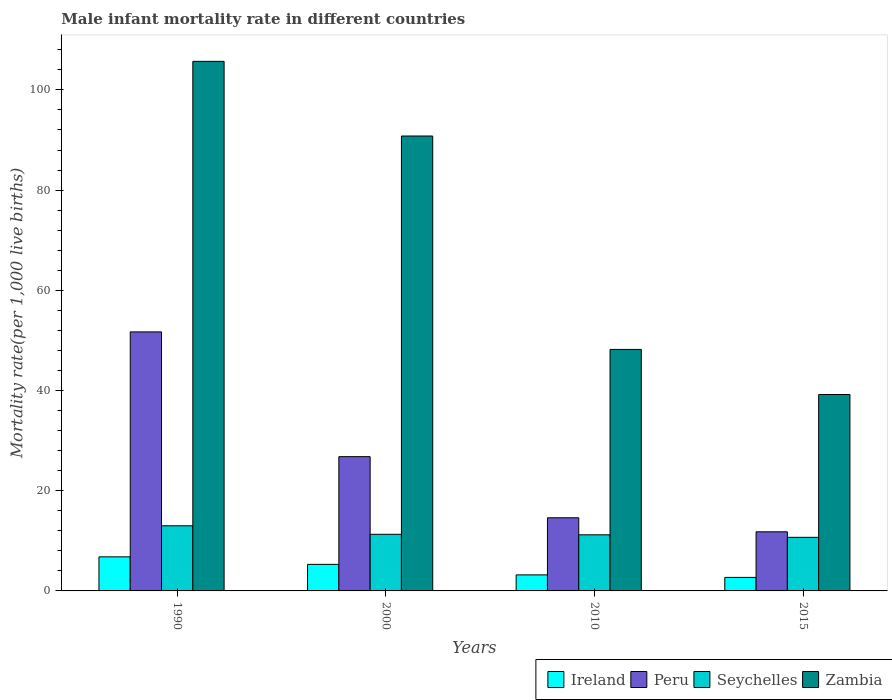How many different coloured bars are there?
Keep it short and to the point. 4. Are the number of bars per tick equal to the number of legend labels?
Your answer should be compact. Yes. How many bars are there on the 1st tick from the right?
Give a very brief answer. 4. What is the label of the 1st group of bars from the left?
Keep it short and to the point. 1990. In how many cases, is the number of bars for a given year not equal to the number of legend labels?
Ensure brevity in your answer.  0. What is the male infant mortality rate in Zambia in 2015?
Ensure brevity in your answer.  39.2. Across all years, what is the maximum male infant mortality rate in Peru?
Ensure brevity in your answer.  51.7. In which year was the male infant mortality rate in Seychelles maximum?
Your answer should be very brief. 1990. In which year was the male infant mortality rate in Seychelles minimum?
Provide a short and direct response. 2015. What is the total male infant mortality rate in Peru in the graph?
Provide a short and direct response. 104.9. What is the difference between the male infant mortality rate in Zambia in 1990 and that in 2010?
Keep it short and to the point. 57.5. What is the average male infant mortality rate in Ireland per year?
Offer a terse response. 4.5. In the year 2010, what is the difference between the male infant mortality rate in Zambia and male infant mortality rate in Seychelles?
Offer a terse response. 37. In how many years, is the male infant mortality rate in Seychelles greater than 16?
Provide a short and direct response. 0. What is the ratio of the male infant mortality rate in Peru in 1990 to that in 2000?
Make the answer very short. 1.93. Is the male infant mortality rate in Seychelles in 2000 less than that in 2010?
Keep it short and to the point. No. What is the difference between the highest and the second highest male infant mortality rate in Ireland?
Your response must be concise. 1.5. What is the difference between the highest and the lowest male infant mortality rate in Peru?
Keep it short and to the point. 39.9. Is the sum of the male infant mortality rate in Seychelles in 1990 and 2000 greater than the maximum male infant mortality rate in Ireland across all years?
Your answer should be very brief. Yes. What does the 1st bar from the left in 2000 represents?
Your answer should be very brief. Ireland. What does the 2nd bar from the right in 2000 represents?
Provide a succinct answer. Seychelles. How many bars are there?
Keep it short and to the point. 16. How many years are there in the graph?
Make the answer very short. 4. How many legend labels are there?
Your response must be concise. 4. How are the legend labels stacked?
Give a very brief answer. Horizontal. What is the title of the graph?
Give a very brief answer. Male infant mortality rate in different countries. Does "Central Europe" appear as one of the legend labels in the graph?
Give a very brief answer. No. What is the label or title of the Y-axis?
Offer a terse response. Mortality rate(per 1,0 live births). What is the Mortality rate(per 1,000 live births) of Peru in 1990?
Offer a very short reply. 51.7. What is the Mortality rate(per 1,000 live births) of Zambia in 1990?
Make the answer very short. 105.7. What is the Mortality rate(per 1,000 live births) in Ireland in 2000?
Give a very brief answer. 5.3. What is the Mortality rate(per 1,000 live births) in Peru in 2000?
Give a very brief answer. 26.8. What is the Mortality rate(per 1,000 live births) in Seychelles in 2000?
Provide a short and direct response. 11.3. What is the Mortality rate(per 1,000 live births) of Zambia in 2000?
Make the answer very short. 90.8. What is the Mortality rate(per 1,000 live births) of Seychelles in 2010?
Provide a succinct answer. 11.2. What is the Mortality rate(per 1,000 live births) of Zambia in 2010?
Keep it short and to the point. 48.2. What is the Mortality rate(per 1,000 live births) in Peru in 2015?
Make the answer very short. 11.8. What is the Mortality rate(per 1,000 live births) in Seychelles in 2015?
Provide a short and direct response. 10.7. What is the Mortality rate(per 1,000 live births) in Zambia in 2015?
Provide a short and direct response. 39.2. Across all years, what is the maximum Mortality rate(per 1,000 live births) of Ireland?
Provide a short and direct response. 6.8. Across all years, what is the maximum Mortality rate(per 1,000 live births) in Peru?
Offer a very short reply. 51.7. Across all years, what is the maximum Mortality rate(per 1,000 live births) of Seychelles?
Provide a succinct answer. 13. Across all years, what is the maximum Mortality rate(per 1,000 live births) of Zambia?
Provide a short and direct response. 105.7. Across all years, what is the minimum Mortality rate(per 1,000 live births) of Seychelles?
Your answer should be very brief. 10.7. Across all years, what is the minimum Mortality rate(per 1,000 live births) in Zambia?
Provide a succinct answer. 39.2. What is the total Mortality rate(per 1,000 live births) in Peru in the graph?
Offer a very short reply. 104.9. What is the total Mortality rate(per 1,000 live births) of Seychelles in the graph?
Keep it short and to the point. 46.2. What is the total Mortality rate(per 1,000 live births) in Zambia in the graph?
Give a very brief answer. 283.9. What is the difference between the Mortality rate(per 1,000 live births) of Peru in 1990 and that in 2000?
Give a very brief answer. 24.9. What is the difference between the Mortality rate(per 1,000 live births) of Zambia in 1990 and that in 2000?
Keep it short and to the point. 14.9. What is the difference between the Mortality rate(per 1,000 live births) of Ireland in 1990 and that in 2010?
Your answer should be compact. 3.6. What is the difference between the Mortality rate(per 1,000 live births) of Peru in 1990 and that in 2010?
Provide a succinct answer. 37.1. What is the difference between the Mortality rate(per 1,000 live births) of Seychelles in 1990 and that in 2010?
Offer a terse response. 1.8. What is the difference between the Mortality rate(per 1,000 live births) of Zambia in 1990 and that in 2010?
Ensure brevity in your answer.  57.5. What is the difference between the Mortality rate(per 1,000 live births) of Ireland in 1990 and that in 2015?
Ensure brevity in your answer.  4.1. What is the difference between the Mortality rate(per 1,000 live births) of Peru in 1990 and that in 2015?
Your answer should be very brief. 39.9. What is the difference between the Mortality rate(per 1,000 live births) of Zambia in 1990 and that in 2015?
Offer a terse response. 66.5. What is the difference between the Mortality rate(per 1,000 live births) of Ireland in 2000 and that in 2010?
Your answer should be very brief. 2.1. What is the difference between the Mortality rate(per 1,000 live births) of Peru in 2000 and that in 2010?
Keep it short and to the point. 12.2. What is the difference between the Mortality rate(per 1,000 live births) of Zambia in 2000 and that in 2010?
Your answer should be compact. 42.6. What is the difference between the Mortality rate(per 1,000 live births) of Ireland in 2000 and that in 2015?
Keep it short and to the point. 2.6. What is the difference between the Mortality rate(per 1,000 live births) of Zambia in 2000 and that in 2015?
Make the answer very short. 51.6. What is the difference between the Mortality rate(per 1,000 live births) in Seychelles in 2010 and that in 2015?
Provide a succinct answer. 0.5. What is the difference between the Mortality rate(per 1,000 live births) in Zambia in 2010 and that in 2015?
Offer a very short reply. 9. What is the difference between the Mortality rate(per 1,000 live births) of Ireland in 1990 and the Mortality rate(per 1,000 live births) of Seychelles in 2000?
Your response must be concise. -4.5. What is the difference between the Mortality rate(per 1,000 live births) in Ireland in 1990 and the Mortality rate(per 1,000 live births) in Zambia in 2000?
Your answer should be compact. -84. What is the difference between the Mortality rate(per 1,000 live births) in Peru in 1990 and the Mortality rate(per 1,000 live births) in Seychelles in 2000?
Keep it short and to the point. 40.4. What is the difference between the Mortality rate(per 1,000 live births) in Peru in 1990 and the Mortality rate(per 1,000 live births) in Zambia in 2000?
Give a very brief answer. -39.1. What is the difference between the Mortality rate(per 1,000 live births) in Seychelles in 1990 and the Mortality rate(per 1,000 live births) in Zambia in 2000?
Your answer should be very brief. -77.8. What is the difference between the Mortality rate(per 1,000 live births) in Ireland in 1990 and the Mortality rate(per 1,000 live births) in Seychelles in 2010?
Make the answer very short. -4.4. What is the difference between the Mortality rate(per 1,000 live births) of Ireland in 1990 and the Mortality rate(per 1,000 live births) of Zambia in 2010?
Ensure brevity in your answer.  -41.4. What is the difference between the Mortality rate(per 1,000 live births) of Peru in 1990 and the Mortality rate(per 1,000 live births) of Seychelles in 2010?
Keep it short and to the point. 40.5. What is the difference between the Mortality rate(per 1,000 live births) of Seychelles in 1990 and the Mortality rate(per 1,000 live births) of Zambia in 2010?
Keep it short and to the point. -35.2. What is the difference between the Mortality rate(per 1,000 live births) of Ireland in 1990 and the Mortality rate(per 1,000 live births) of Seychelles in 2015?
Provide a short and direct response. -3.9. What is the difference between the Mortality rate(per 1,000 live births) of Ireland in 1990 and the Mortality rate(per 1,000 live births) of Zambia in 2015?
Give a very brief answer. -32.4. What is the difference between the Mortality rate(per 1,000 live births) in Seychelles in 1990 and the Mortality rate(per 1,000 live births) in Zambia in 2015?
Your response must be concise. -26.2. What is the difference between the Mortality rate(per 1,000 live births) of Ireland in 2000 and the Mortality rate(per 1,000 live births) of Zambia in 2010?
Keep it short and to the point. -42.9. What is the difference between the Mortality rate(per 1,000 live births) of Peru in 2000 and the Mortality rate(per 1,000 live births) of Seychelles in 2010?
Ensure brevity in your answer.  15.6. What is the difference between the Mortality rate(per 1,000 live births) of Peru in 2000 and the Mortality rate(per 1,000 live births) of Zambia in 2010?
Your answer should be very brief. -21.4. What is the difference between the Mortality rate(per 1,000 live births) in Seychelles in 2000 and the Mortality rate(per 1,000 live births) in Zambia in 2010?
Your answer should be very brief. -36.9. What is the difference between the Mortality rate(per 1,000 live births) in Ireland in 2000 and the Mortality rate(per 1,000 live births) in Peru in 2015?
Offer a terse response. -6.5. What is the difference between the Mortality rate(per 1,000 live births) in Ireland in 2000 and the Mortality rate(per 1,000 live births) in Zambia in 2015?
Keep it short and to the point. -33.9. What is the difference between the Mortality rate(per 1,000 live births) in Peru in 2000 and the Mortality rate(per 1,000 live births) in Seychelles in 2015?
Give a very brief answer. 16.1. What is the difference between the Mortality rate(per 1,000 live births) in Peru in 2000 and the Mortality rate(per 1,000 live births) in Zambia in 2015?
Your answer should be very brief. -12.4. What is the difference between the Mortality rate(per 1,000 live births) in Seychelles in 2000 and the Mortality rate(per 1,000 live births) in Zambia in 2015?
Make the answer very short. -27.9. What is the difference between the Mortality rate(per 1,000 live births) in Ireland in 2010 and the Mortality rate(per 1,000 live births) in Peru in 2015?
Your answer should be compact. -8.6. What is the difference between the Mortality rate(per 1,000 live births) in Ireland in 2010 and the Mortality rate(per 1,000 live births) in Seychelles in 2015?
Make the answer very short. -7.5. What is the difference between the Mortality rate(per 1,000 live births) in Ireland in 2010 and the Mortality rate(per 1,000 live births) in Zambia in 2015?
Offer a terse response. -36. What is the difference between the Mortality rate(per 1,000 live births) of Peru in 2010 and the Mortality rate(per 1,000 live births) of Seychelles in 2015?
Offer a very short reply. 3.9. What is the difference between the Mortality rate(per 1,000 live births) of Peru in 2010 and the Mortality rate(per 1,000 live births) of Zambia in 2015?
Your response must be concise. -24.6. What is the difference between the Mortality rate(per 1,000 live births) of Seychelles in 2010 and the Mortality rate(per 1,000 live births) of Zambia in 2015?
Your response must be concise. -28. What is the average Mortality rate(per 1,000 live births) in Peru per year?
Provide a succinct answer. 26.23. What is the average Mortality rate(per 1,000 live births) of Seychelles per year?
Your answer should be compact. 11.55. What is the average Mortality rate(per 1,000 live births) of Zambia per year?
Provide a succinct answer. 70.97. In the year 1990, what is the difference between the Mortality rate(per 1,000 live births) of Ireland and Mortality rate(per 1,000 live births) of Peru?
Your answer should be very brief. -44.9. In the year 1990, what is the difference between the Mortality rate(per 1,000 live births) of Ireland and Mortality rate(per 1,000 live births) of Zambia?
Offer a terse response. -98.9. In the year 1990, what is the difference between the Mortality rate(per 1,000 live births) in Peru and Mortality rate(per 1,000 live births) in Seychelles?
Your answer should be very brief. 38.7. In the year 1990, what is the difference between the Mortality rate(per 1,000 live births) of Peru and Mortality rate(per 1,000 live births) of Zambia?
Provide a succinct answer. -54. In the year 1990, what is the difference between the Mortality rate(per 1,000 live births) of Seychelles and Mortality rate(per 1,000 live births) of Zambia?
Give a very brief answer. -92.7. In the year 2000, what is the difference between the Mortality rate(per 1,000 live births) in Ireland and Mortality rate(per 1,000 live births) in Peru?
Your answer should be very brief. -21.5. In the year 2000, what is the difference between the Mortality rate(per 1,000 live births) in Ireland and Mortality rate(per 1,000 live births) in Seychelles?
Give a very brief answer. -6. In the year 2000, what is the difference between the Mortality rate(per 1,000 live births) of Ireland and Mortality rate(per 1,000 live births) of Zambia?
Offer a very short reply. -85.5. In the year 2000, what is the difference between the Mortality rate(per 1,000 live births) in Peru and Mortality rate(per 1,000 live births) in Zambia?
Offer a very short reply. -64. In the year 2000, what is the difference between the Mortality rate(per 1,000 live births) of Seychelles and Mortality rate(per 1,000 live births) of Zambia?
Your answer should be compact. -79.5. In the year 2010, what is the difference between the Mortality rate(per 1,000 live births) of Ireland and Mortality rate(per 1,000 live births) of Peru?
Your answer should be compact. -11.4. In the year 2010, what is the difference between the Mortality rate(per 1,000 live births) of Ireland and Mortality rate(per 1,000 live births) of Zambia?
Offer a terse response. -45. In the year 2010, what is the difference between the Mortality rate(per 1,000 live births) of Peru and Mortality rate(per 1,000 live births) of Zambia?
Make the answer very short. -33.6. In the year 2010, what is the difference between the Mortality rate(per 1,000 live births) of Seychelles and Mortality rate(per 1,000 live births) of Zambia?
Offer a very short reply. -37. In the year 2015, what is the difference between the Mortality rate(per 1,000 live births) of Ireland and Mortality rate(per 1,000 live births) of Peru?
Your response must be concise. -9.1. In the year 2015, what is the difference between the Mortality rate(per 1,000 live births) in Ireland and Mortality rate(per 1,000 live births) in Seychelles?
Your answer should be very brief. -8. In the year 2015, what is the difference between the Mortality rate(per 1,000 live births) of Ireland and Mortality rate(per 1,000 live births) of Zambia?
Your response must be concise. -36.5. In the year 2015, what is the difference between the Mortality rate(per 1,000 live births) of Peru and Mortality rate(per 1,000 live births) of Seychelles?
Your answer should be compact. 1.1. In the year 2015, what is the difference between the Mortality rate(per 1,000 live births) in Peru and Mortality rate(per 1,000 live births) in Zambia?
Offer a very short reply. -27.4. In the year 2015, what is the difference between the Mortality rate(per 1,000 live births) of Seychelles and Mortality rate(per 1,000 live births) of Zambia?
Provide a short and direct response. -28.5. What is the ratio of the Mortality rate(per 1,000 live births) in Ireland in 1990 to that in 2000?
Keep it short and to the point. 1.28. What is the ratio of the Mortality rate(per 1,000 live births) in Peru in 1990 to that in 2000?
Make the answer very short. 1.93. What is the ratio of the Mortality rate(per 1,000 live births) in Seychelles in 1990 to that in 2000?
Offer a very short reply. 1.15. What is the ratio of the Mortality rate(per 1,000 live births) in Zambia in 1990 to that in 2000?
Provide a succinct answer. 1.16. What is the ratio of the Mortality rate(per 1,000 live births) in Ireland in 1990 to that in 2010?
Ensure brevity in your answer.  2.12. What is the ratio of the Mortality rate(per 1,000 live births) in Peru in 1990 to that in 2010?
Offer a terse response. 3.54. What is the ratio of the Mortality rate(per 1,000 live births) of Seychelles in 1990 to that in 2010?
Provide a succinct answer. 1.16. What is the ratio of the Mortality rate(per 1,000 live births) in Zambia in 1990 to that in 2010?
Give a very brief answer. 2.19. What is the ratio of the Mortality rate(per 1,000 live births) in Ireland in 1990 to that in 2015?
Provide a short and direct response. 2.52. What is the ratio of the Mortality rate(per 1,000 live births) of Peru in 1990 to that in 2015?
Offer a very short reply. 4.38. What is the ratio of the Mortality rate(per 1,000 live births) in Seychelles in 1990 to that in 2015?
Offer a terse response. 1.22. What is the ratio of the Mortality rate(per 1,000 live births) of Zambia in 1990 to that in 2015?
Provide a succinct answer. 2.7. What is the ratio of the Mortality rate(per 1,000 live births) in Ireland in 2000 to that in 2010?
Keep it short and to the point. 1.66. What is the ratio of the Mortality rate(per 1,000 live births) of Peru in 2000 to that in 2010?
Provide a short and direct response. 1.84. What is the ratio of the Mortality rate(per 1,000 live births) in Seychelles in 2000 to that in 2010?
Your answer should be very brief. 1.01. What is the ratio of the Mortality rate(per 1,000 live births) in Zambia in 2000 to that in 2010?
Keep it short and to the point. 1.88. What is the ratio of the Mortality rate(per 1,000 live births) in Ireland in 2000 to that in 2015?
Offer a very short reply. 1.96. What is the ratio of the Mortality rate(per 1,000 live births) in Peru in 2000 to that in 2015?
Provide a short and direct response. 2.27. What is the ratio of the Mortality rate(per 1,000 live births) in Seychelles in 2000 to that in 2015?
Keep it short and to the point. 1.06. What is the ratio of the Mortality rate(per 1,000 live births) in Zambia in 2000 to that in 2015?
Your response must be concise. 2.32. What is the ratio of the Mortality rate(per 1,000 live births) of Ireland in 2010 to that in 2015?
Your response must be concise. 1.19. What is the ratio of the Mortality rate(per 1,000 live births) in Peru in 2010 to that in 2015?
Offer a terse response. 1.24. What is the ratio of the Mortality rate(per 1,000 live births) of Seychelles in 2010 to that in 2015?
Your answer should be very brief. 1.05. What is the ratio of the Mortality rate(per 1,000 live births) of Zambia in 2010 to that in 2015?
Keep it short and to the point. 1.23. What is the difference between the highest and the second highest Mortality rate(per 1,000 live births) of Ireland?
Make the answer very short. 1.5. What is the difference between the highest and the second highest Mortality rate(per 1,000 live births) of Peru?
Provide a succinct answer. 24.9. What is the difference between the highest and the second highest Mortality rate(per 1,000 live births) of Seychelles?
Give a very brief answer. 1.7. What is the difference between the highest and the second highest Mortality rate(per 1,000 live births) of Zambia?
Offer a very short reply. 14.9. What is the difference between the highest and the lowest Mortality rate(per 1,000 live births) of Peru?
Provide a short and direct response. 39.9. What is the difference between the highest and the lowest Mortality rate(per 1,000 live births) of Zambia?
Your response must be concise. 66.5. 